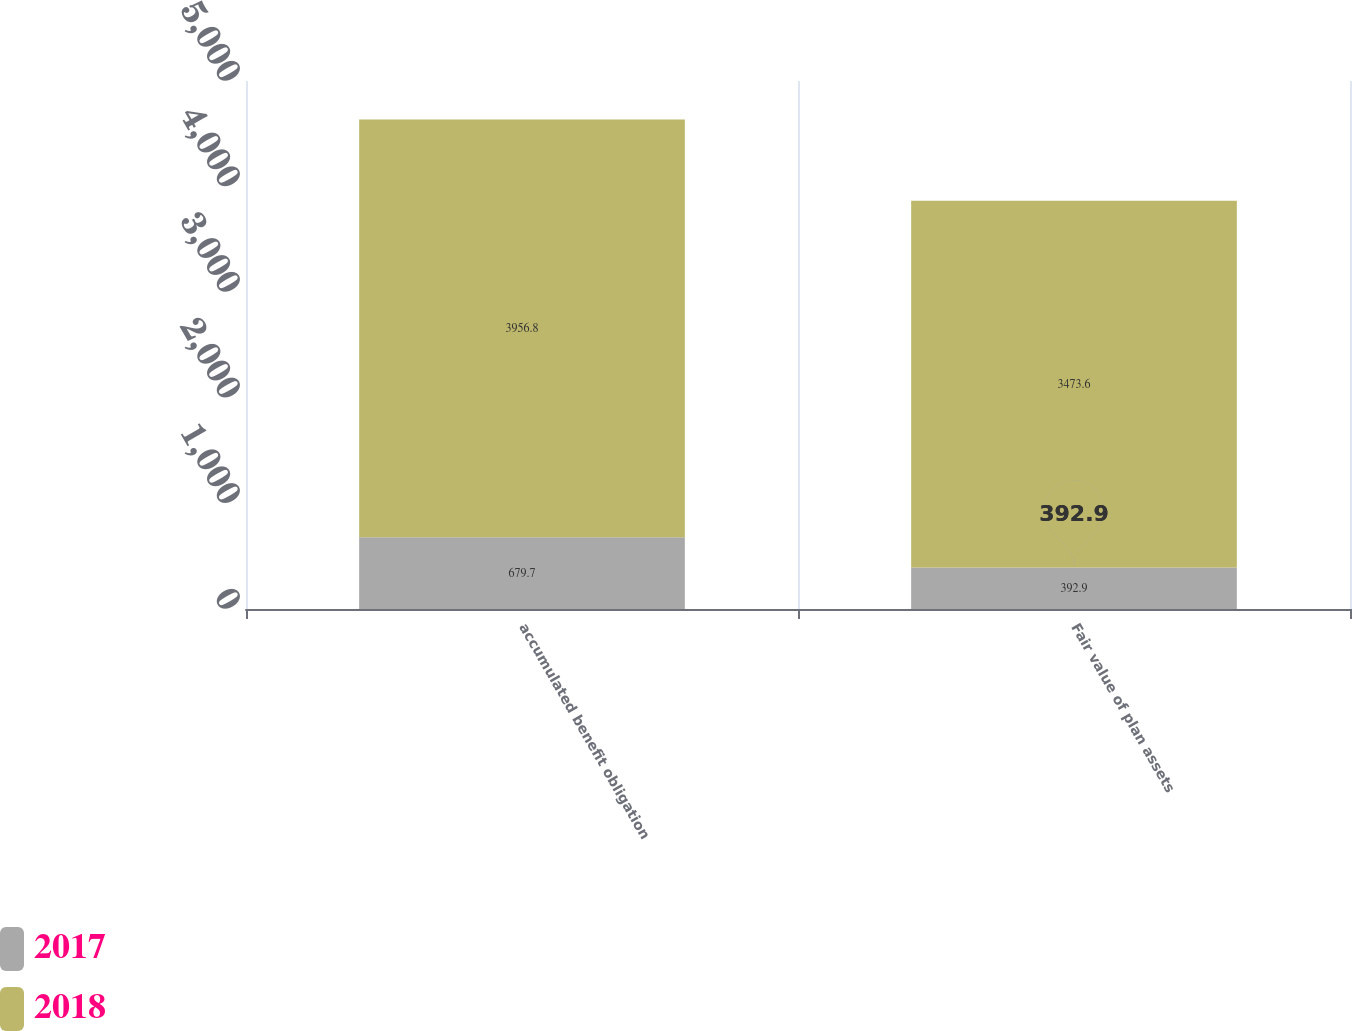<chart> <loc_0><loc_0><loc_500><loc_500><stacked_bar_chart><ecel><fcel>accumulated benefit obligation<fcel>Fair value of plan assets<nl><fcel>2017<fcel>679.7<fcel>392.9<nl><fcel>2018<fcel>3956.8<fcel>3473.6<nl></chart> 